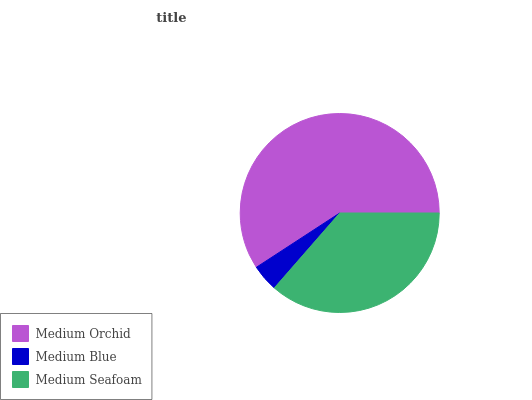Is Medium Blue the minimum?
Answer yes or no. Yes. Is Medium Orchid the maximum?
Answer yes or no. Yes. Is Medium Seafoam the minimum?
Answer yes or no. No. Is Medium Seafoam the maximum?
Answer yes or no. No. Is Medium Seafoam greater than Medium Blue?
Answer yes or no. Yes. Is Medium Blue less than Medium Seafoam?
Answer yes or no. Yes. Is Medium Blue greater than Medium Seafoam?
Answer yes or no. No. Is Medium Seafoam less than Medium Blue?
Answer yes or no. No. Is Medium Seafoam the high median?
Answer yes or no. Yes. Is Medium Seafoam the low median?
Answer yes or no. Yes. Is Medium Blue the high median?
Answer yes or no. No. Is Medium Orchid the low median?
Answer yes or no. No. 